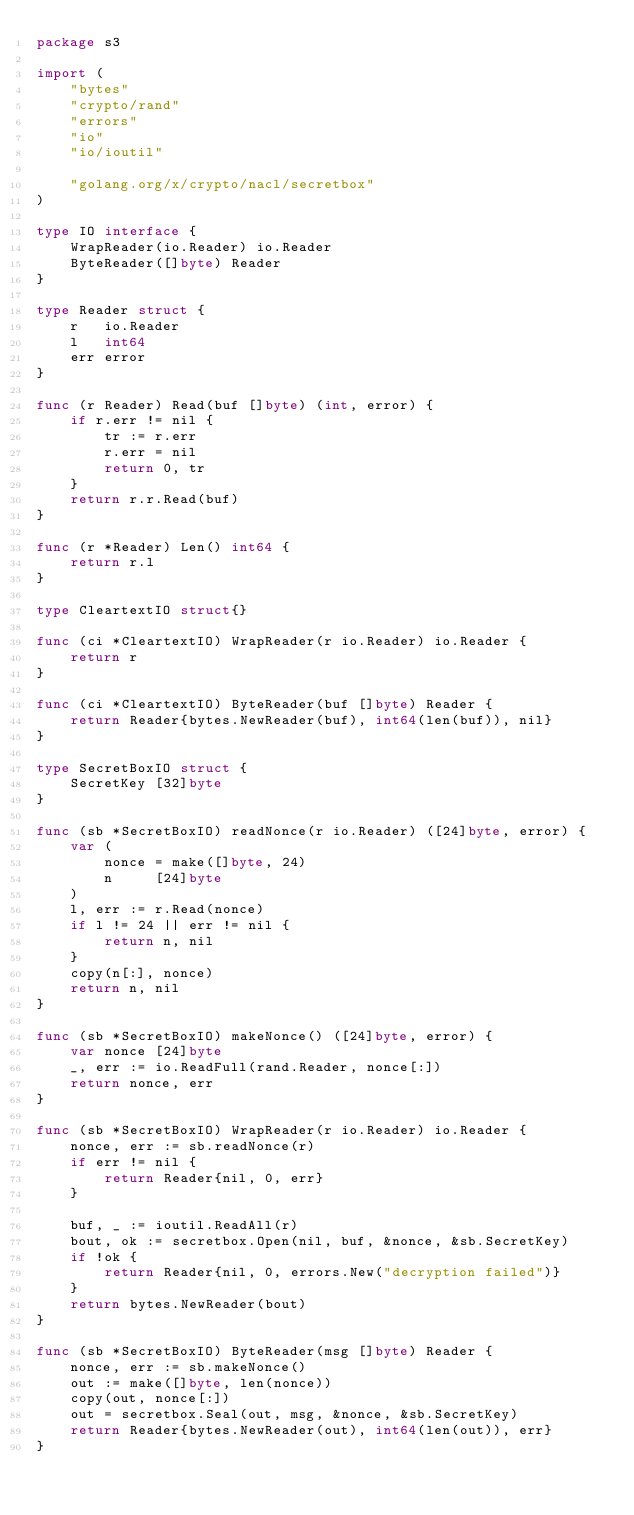<code> <loc_0><loc_0><loc_500><loc_500><_Go_>package s3

import (
	"bytes"
	"crypto/rand"
	"errors"
	"io"
	"io/ioutil"

	"golang.org/x/crypto/nacl/secretbox"
)

type IO interface {
	WrapReader(io.Reader) io.Reader
	ByteReader([]byte) Reader
}

type Reader struct {
	r   io.Reader
	l   int64
	err error
}

func (r Reader) Read(buf []byte) (int, error) {
	if r.err != nil {
		tr := r.err
		r.err = nil
		return 0, tr
	}
	return r.r.Read(buf)
}

func (r *Reader) Len() int64 {
	return r.l
}

type CleartextIO struct{}

func (ci *CleartextIO) WrapReader(r io.Reader) io.Reader {
	return r
}

func (ci *CleartextIO) ByteReader(buf []byte) Reader {
	return Reader{bytes.NewReader(buf), int64(len(buf)), nil}
}

type SecretBoxIO struct {
	SecretKey [32]byte
}

func (sb *SecretBoxIO) readNonce(r io.Reader) ([24]byte, error) {
	var (
		nonce = make([]byte, 24)
		n     [24]byte
	)
	l, err := r.Read(nonce)
	if l != 24 || err != nil {
		return n, nil
	}
	copy(n[:], nonce)
	return n, nil
}

func (sb *SecretBoxIO) makeNonce() ([24]byte, error) {
	var nonce [24]byte
	_, err := io.ReadFull(rand.Reader, nonce[:])
	return nonce, err
}

func (sb *SecretBoxIO) WrapReader(r io.Reader) io.Reader {
	nonce, err := sb.readNonce(r)
	if err != nil {
		return Reader{nil, 0, err}
	}

	buf, _ := ioutil.ReadAll(r)
	bout, ok := secretbox.Open(nil, buf, &nonce, &sb.SecretKey)
	if !ok {
		return Reader{nil, 0, errors.New("decryption failed")}
	}
	return bytes.NewReader(bout)
}

func (sb *SecretBoxIO) ByteReader(msg []byte) Reader {
	nonce, err := sb.makeNonce()
	out := make([]byte, len(nonce))
	copy(out, nonce[:])
	out = secretbox.Seal(out, msg, &nonce, &sb.SecretKey)
	return Reader{bytes.NewReader(out), int64(len(out)), err}
}
</code> 